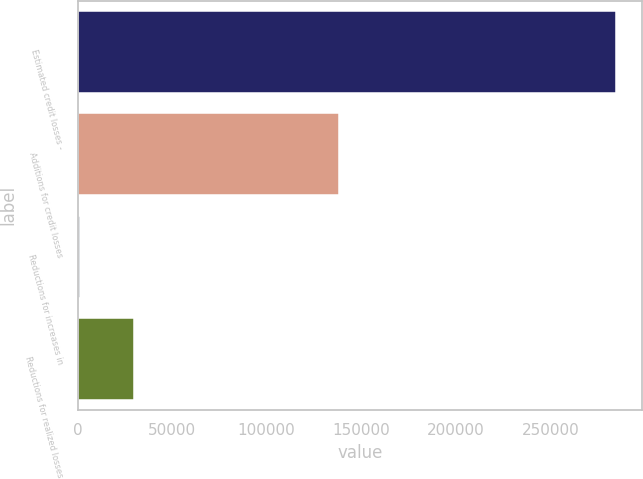<chart> <loc_0><loc_0><loc_500><loc_500><bar_chart><fcel>Estimated credit losses -<fcel>Additions for credit losses<fcel>Reductions for increases in<fcel>Reductions for realized losses<nl><fcel>284513<fcel>138297<fcel>1393<fcel>29705<nl></chart> 